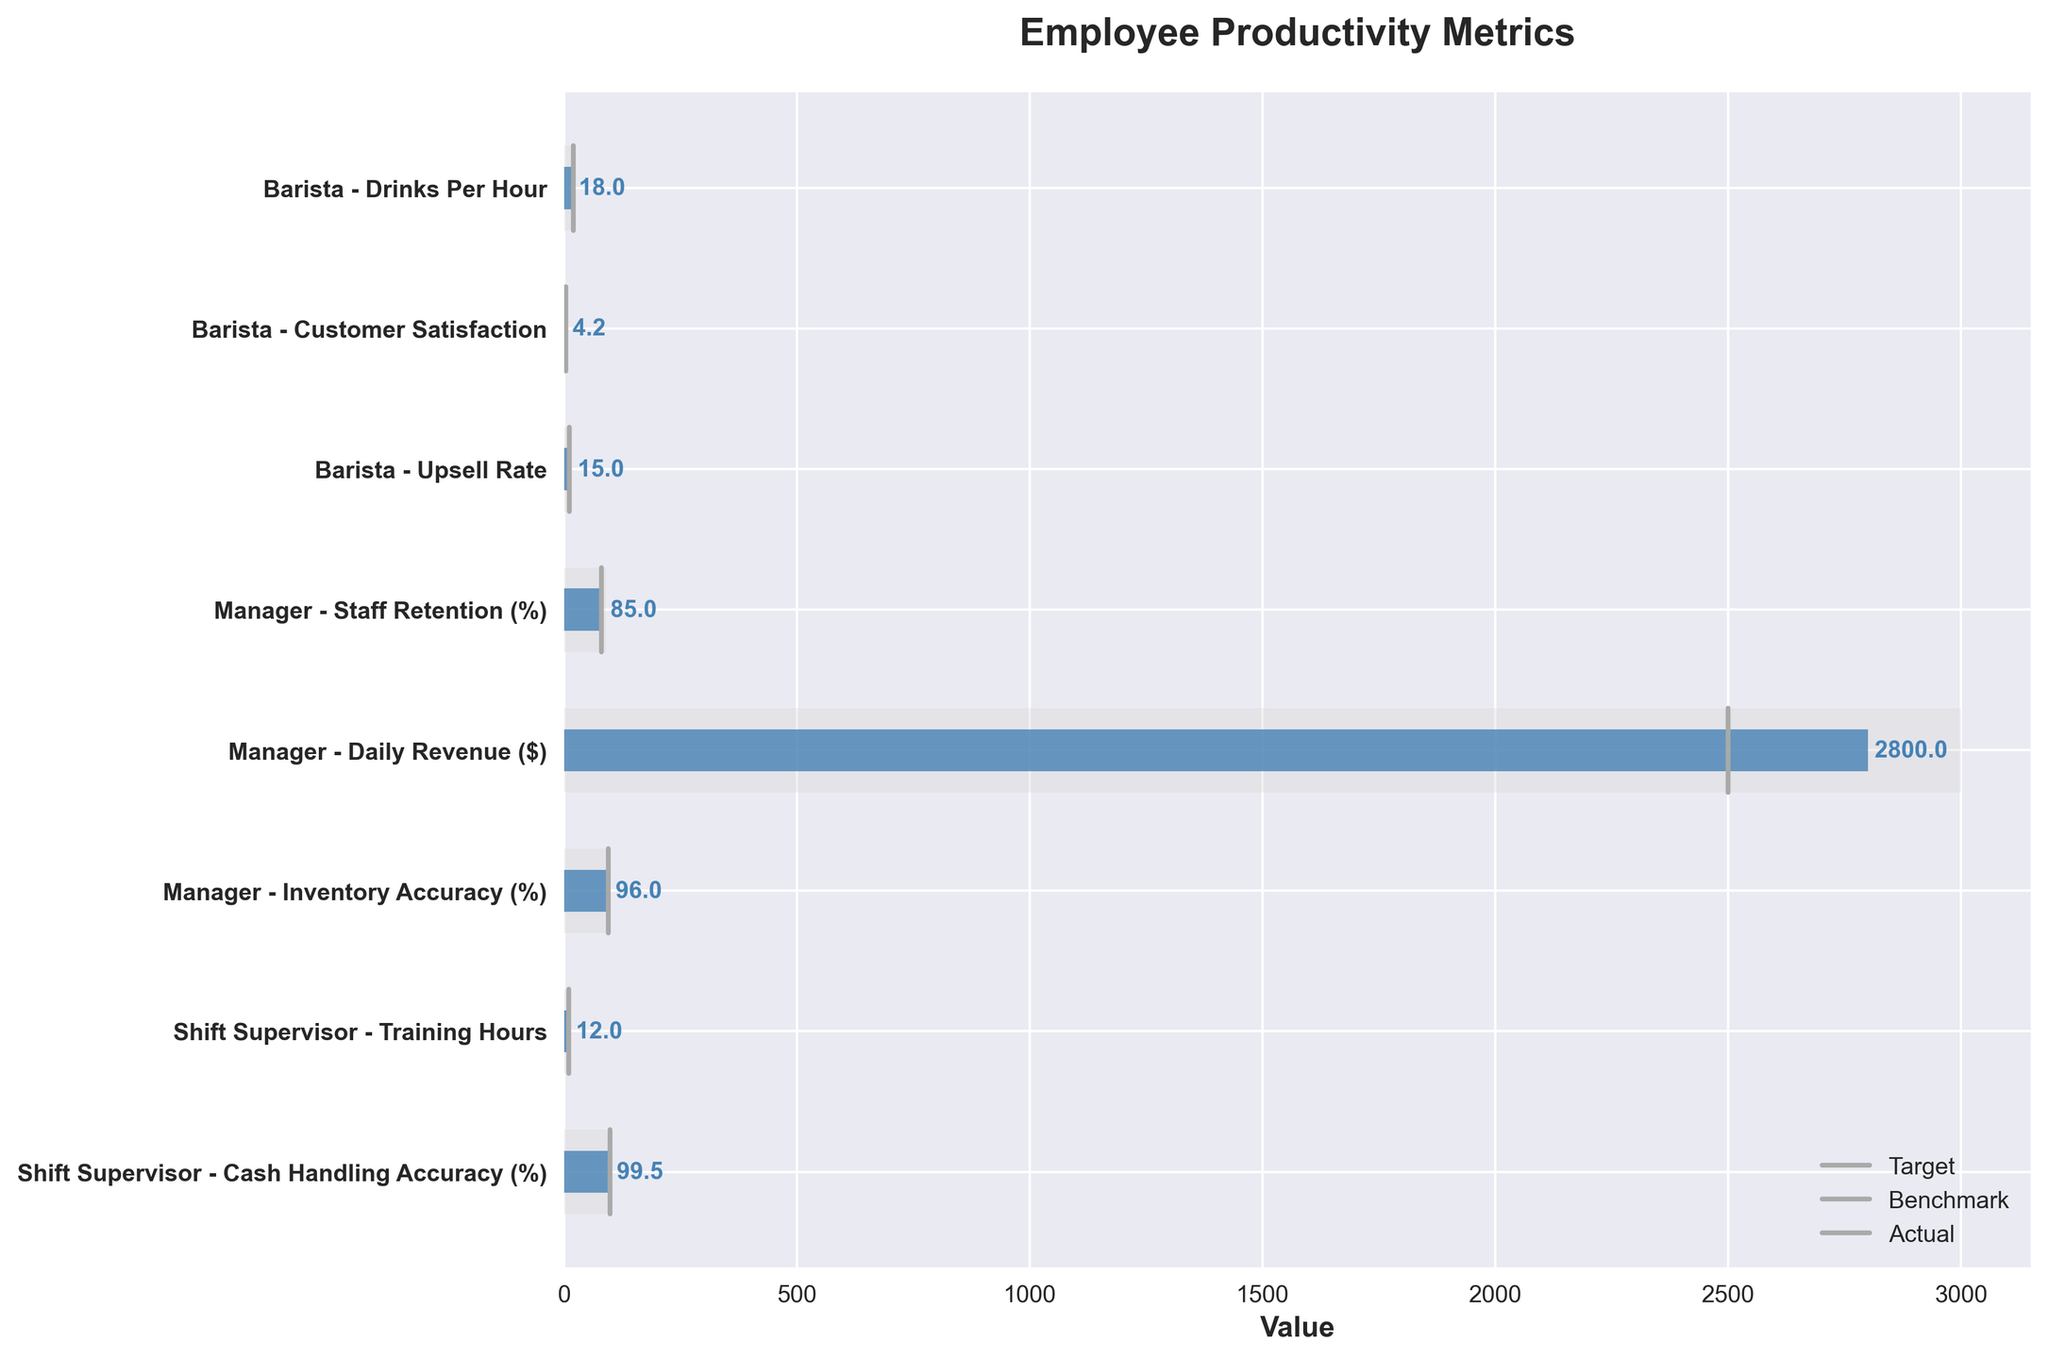What's the title of the chart? The title is usually located at the top of the chart in a larger font size. It gives a summary of what the chart is about. Here, it is "Employee Productivity Metrics".
Answer: Employee Productivity Metrics What is the actual value for barista drinks per hour? Look at the bar labeled "Barista - Drinks Per Hour" and locate the number at the end of the blue bar, which represents the actual value.
Answer: 18 What's the difference between the actual and the target value for manager daily revenue? Locate the bar labeled "Manager - Daily Revenue ($)". Identify the actual value, which is marked by the end of the blue bar (2800), and the target value by the end of the grey background bar (3000). Subtract the actual from the target: 3000 - 2800 = 200.
Answer: 200 Which role has the closest actual value to its benchmark in terms of inventory accuracy? Check all actual and benchmark values for roles that include inventory accuracy. Both are approximately the same for the Manager role with an actual of 96 and a benchmark of 95.
Answer: Manager What is the average actual value for barista upsell rate and shift supervisor training hours? Sum the actual values for both "Barista - Upsell Rate" (15) and "Shift Supervisor - Training Hours" (12), then divide by 2: (15 + 12) / 2 = 13.5.
Answer: 13.5 Which employee role exceeds its benchmark in customer satisfaction? Locate the bar for "Barista - Customer Satisfaction". The actual value (4.2) exceeds the benchmark (4.0).
Answer: Barista - Customer Satisfaction How much higher is the actual staff retention percentage for managers compared to the benchmark? Look at the "Manager - Staff Retention (%)" bar. The actual value is 85, and the benchmark is 80. The difference is 85 - 80 = 5.
Answer: 5 Is any role meeting or exceeding its target for cash handling accuracy? Identify the role related to cash handling accuracy, which is "Shift Supervisor - Cash Handling Accuracy (%)". Compare the actual value (99.5) to the target (99.8). The actual does not meet or exceed the target.
Answer: No What's the range between the highest and lowest actual values in the chart? First identify the highest (Manager - Daily Revenue: 2800) and the lowest (Shift Supervisor - Training Hours: 12). The range is 2800 - 12 = 2788.
Answer: 2788 